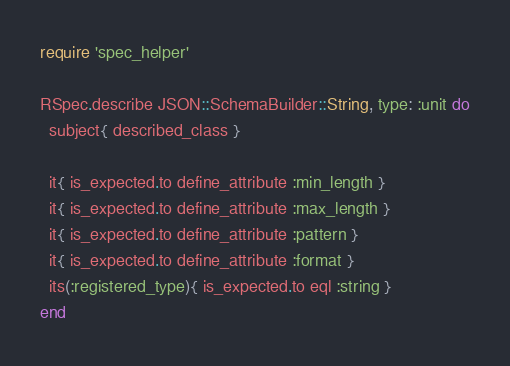<code> <loc_0><loc_0><loc_500><loc_500><_Ruby_>require 'spec_helper'

RSpec.describe JSON::SchemaBuilder::String, type: :unit do
  subject{ described_class }

  it{ is_expected.to define_attribute :min_length }
  it{ is_expected.to define_attribute :max_length }
  it{ is_expected.to define_attribute :pattern }
  it{ is_expected.to define_attribute :format }
  its(:registered_type){ is_expected.to eql :string }
end
</code> 